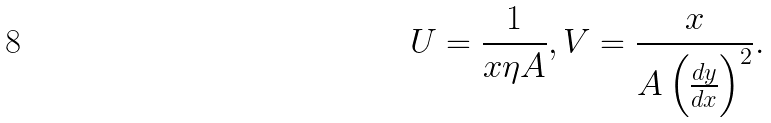Convert formula to latex. <formula><loc_0><loc_0><loc_500><loc_500>U = \frac { 1 } { x \eta A } , V = \frac { x } { A \left ( \frac { d y } { d x } \right ) ^ { 2 } } .</formula> 